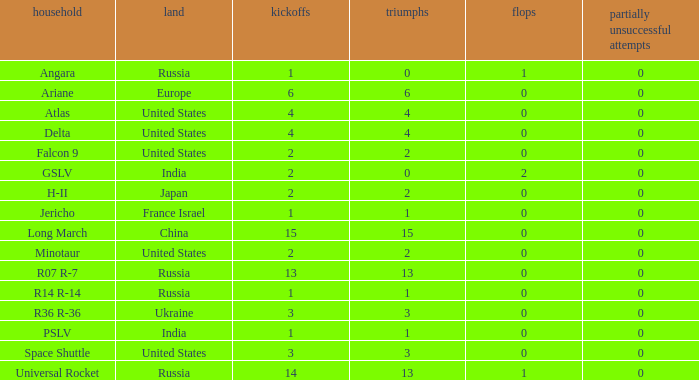What is the partial collapse for the country of russia, and a failure bigger than 0, and a family of angara, and a launch higher than 1? None. 